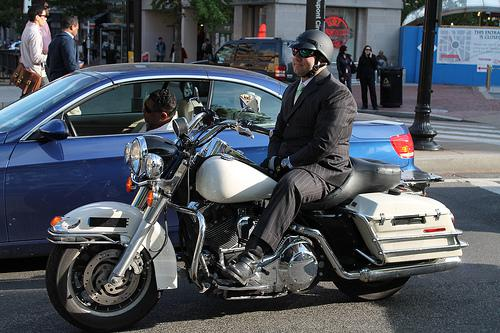Question: what is the color of the wall with the white sign?
Choices:
A. Purple.
B. Green.
C. Red.
D. Blue.
Answer with the letter. Answer: D Question: why is the man not holding the handlebars on the bike?
Choices:
A. He's waiting.
B. He is stopped.
C. He let go.
D. He crashed.
Answer with the letter. Answer: B Question: who is wearing a helmet?
Choices:
A. The boy on the bike.
B. The girl on the skateboard.
C. The man on the scooter.
D. The man on the motorcycle.
Answer with the letter. Answer: D Question: how is the weather?
Choices:
A. Bright.
B. Rainy.
C. Cloudy.
D. Sunny.
Answer with the letter. Answer: D Question: what is the woman by the trash can doing?
Choices:
A. Smoking.
B. Talking on phone.
C. Playing a handheld game.
D. Using her tablet.
Answer with the letter. Answer: B 